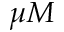<formula> <loc_0><loc_0><loc_500><loc_500>\mu M</formula> 